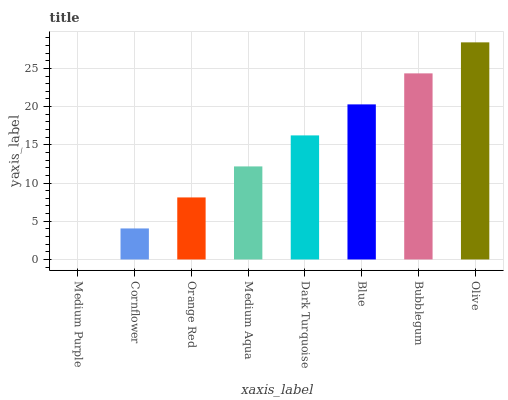Is Cornflower the minimum?
Answer yes or no. No. Is Cornflower the maximum?
Answer yes or no. No. Is Cornflower greater than Medium Purple?
Answer yes or no. Yes. Is Medium Purple less than Cornflower?
Answer yes or no. Yes. Is Medium Purple greater than Cornflower?
Answer yes or no. No. Is Cornflower less than Medium Purple?
Answer yes or no. No. Is Dark Turquoise the high median?
Answer yes or no. Yes. Is Medium Aqua the low median?
Answer yes or no. Yes. Is Medium Aqua the high median?
Answer yes or no. No. Is Blue the low median?
Answer yes or no. No. 